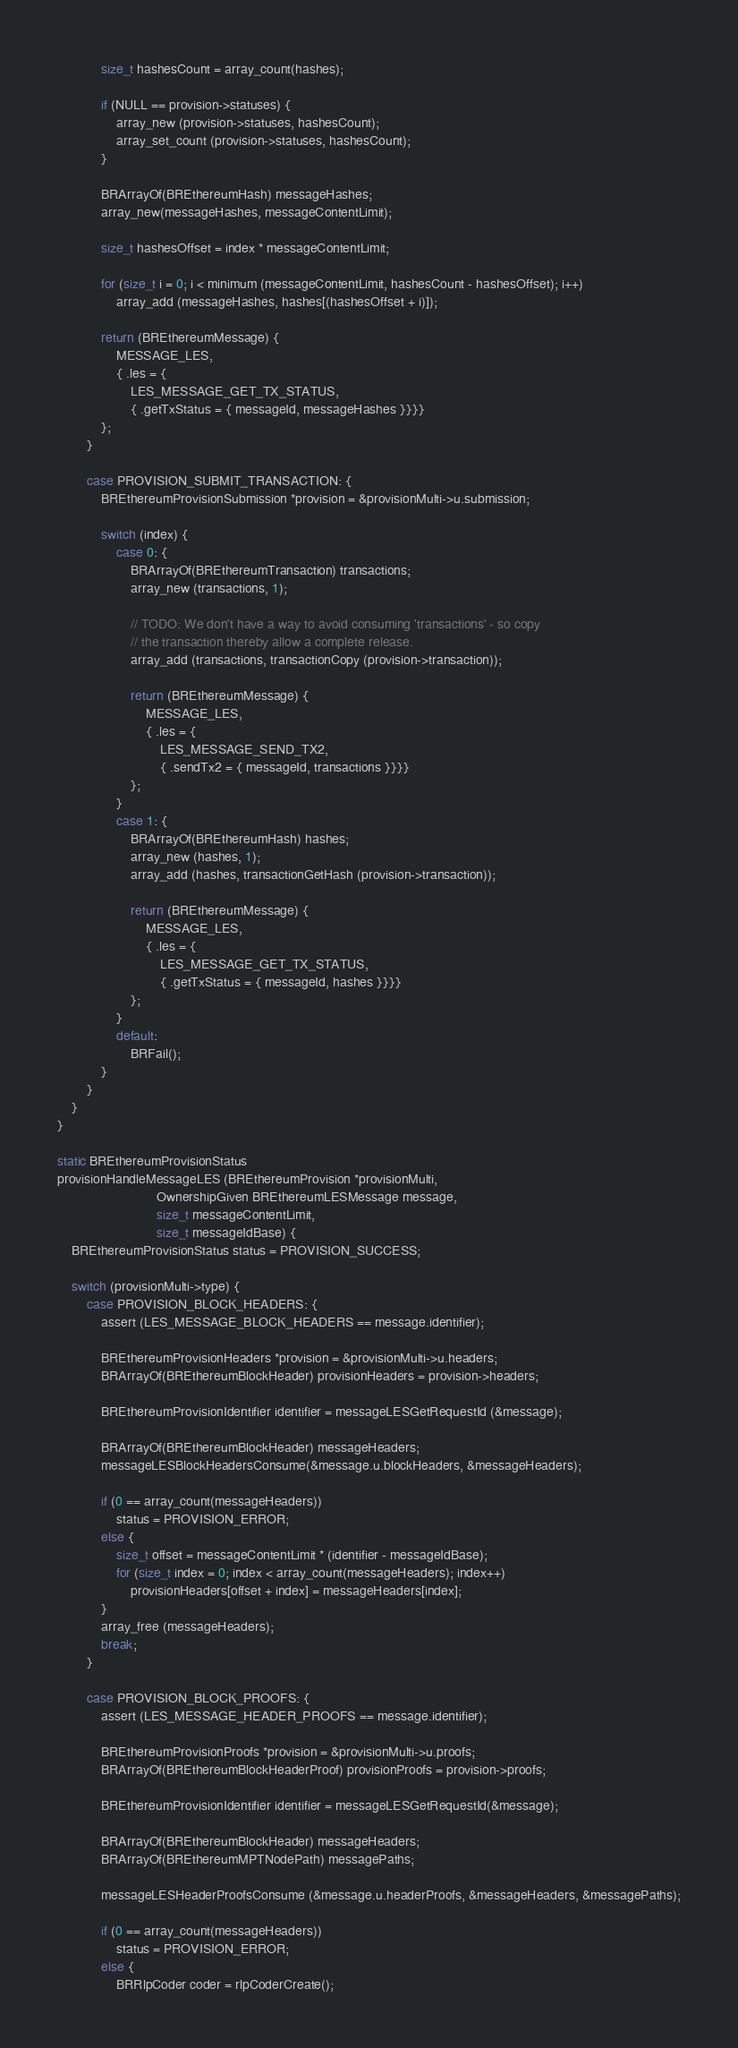Convert code to text. <code><loc_0><loc_0><loc_500><loc_500><_C_>            size_t hashesCount = array_count(hashes);

            if (NULL == provision->statuses) {
                array_new (provision->statuses, hashesCount);
                array_set_count (provision->statuses, hashesCount);
            }

            BRArrayOf(BREthereumHash) messageHashes;
            array_new(messageHashes, messageContentLimit);

            size_t hashesOffset = index * messageContentLimit;

            for (size_t i = 0; i < minimum (messageContentLimit, hashesCount - hashesOffset); i++)
                array_add (messageHashes, hashes[(hashesOffset + i)]);

            return (BREthereumMessage) {
                MESSAGE_LES,
                { .les = {
                    LES_MESSAGE_GET_TX_STATUS,
                    { .getTxStatus = { messageId, messageHashes }}}}
            };
        }

        case PROVISION_SUBMIT_TRANSACTION: {
            BREthereumProvisionSubmission *provision = &provisionMulti->u.submission;

            switch (index) {
                case 0: {
                    BRArrayOf(BREthereumTransaction) transactions;
                    array_new (transactions, 1);

                    // TODO: We don't have a way to avoid consuming 'transactions' - so copy
                    // the transaction thereby allow a complete release.
                    array_add (transactions, transactionCopy (provision->transaction));

                    return (BREthereumMessage) {
                        MESSAGE_LES,
                        { .les = {
                            LES_MESSAGE_SEND_TX2,
                            { .sendTx2 = { messageId, transactions }}}}
                    };
                }
                case 1: {
                    BRArrayOf(BREthereumHash) hashes;
                    array_new (hashes, 1);
                    array_add (hashes, transactionGetHash (provision->transaction));

                    return (BREthereumMessage) {
                        MESSAGE_LES,
                        { .les = {
                            LES_MESSAGE_GET_TX_STATUS,
                            { .getTxStatus = { messageId, hashes }}}}
                    };
                }
                default:
                    BRFail();
            }
        }
    }
}

static BREthereumProvisionStatus
provisionHandleMessageLES (BREthereumProvision *provisionMulti,
                           OwnershipGiven BREthereumLESMessage message,
                           size_t messageContentLimit,
                           size_t messageIdBase) {
    BREthereumProvisionStatus status = PROVISION_SUCCESS;

    switch (provisionMulti->type) {
        case PROVISION_BLOCK_HEADERS: {
            assert (LES_MESSAGE_BLOCK_HEADERS == message.identifier);

            BREthereumProvisionHeaders *provision = &provisionMulti->u.headers;
            BRArrayOf(BREthereumBlockHeader) provisionHeaders = provision->headers;

            BREthereumProvisionIdentifier identifier = messageLESGetRequestId (&message);

            BRArrayOf(BREthereumBlockHeader) messageHeaders;
            messageLESBlockHeadersConsume(&message.u.blockHeaders, &messageHeaders);

            if (0 == array_count(messageHeaders))
                status = PROVISION_ERROR;
            else {
                size_t offset = messageContentLimit * (identifier - messageIdBase);
                for (size_t index = 0; index < array_count(messageHeaders); index++)
                    provisionHeaders[offset + index] = messageHeaders[index];
            }
            array_free (messageHeaders);
            break;
        }

        case PROVISION_BLOCK_PROOFS: {
            assert (LES_MESSAGE_HEADER_PROOFS == message.identifier);

            BREthereumProvisionProofs *provision = &provisionMulti->u.proofs;
            BRArrayOf(BREthereumBlockHeaderProof) provisionProofs = provision->proofs;

            BREthereumProvisionIdentifier identifier = messageLESGetRequestId(&message);

            BRArrayOf(BREthereumBlockHeader) messageHeaders;
            BRArrayOf(BREthereumMPTNodePath) messagePaths;

            messageLESHeaderProofsConsume (&message.u.headerProofs, &messageHeaders, &messagePaths);

            if (0 == array_count(messageHeaders))
                status = PROVISION_ERROR;
            else {
                BRRlpCoder coder = rlpCoderCreate();
</code> 